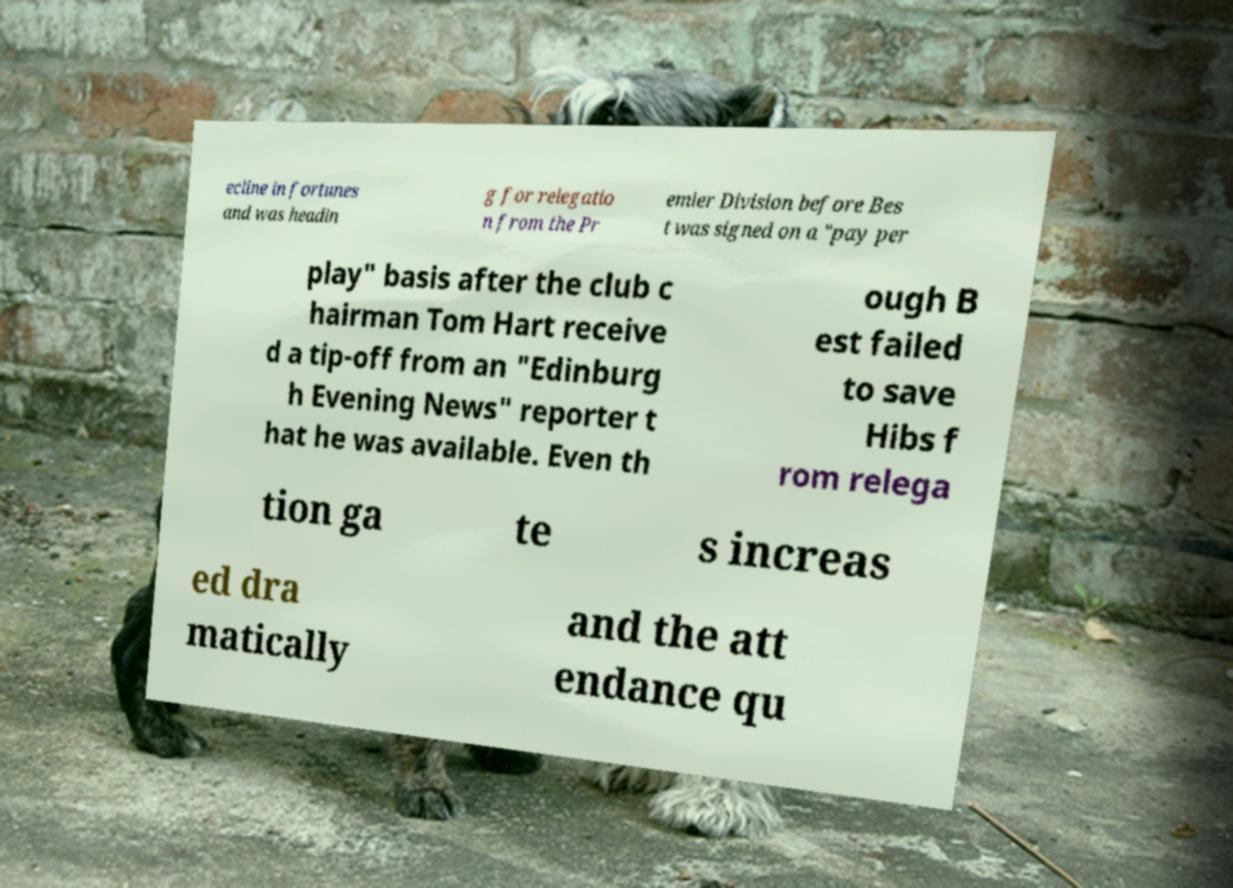What messages or text are displayed in this image? I need them in a readable, typed format. ecline in fortunes and was headin g for relegatio n from the Pr emier Division before Bes t was signed on a "pay per play" basis after the club c hairman Tom Hart receive d a tip-off from an "Edinburg h Evening News" reporter t hat he was available. Even th ough B est failed to save Hibs f rom relega tion ga te s increas ed dra matically and the att endance qu 